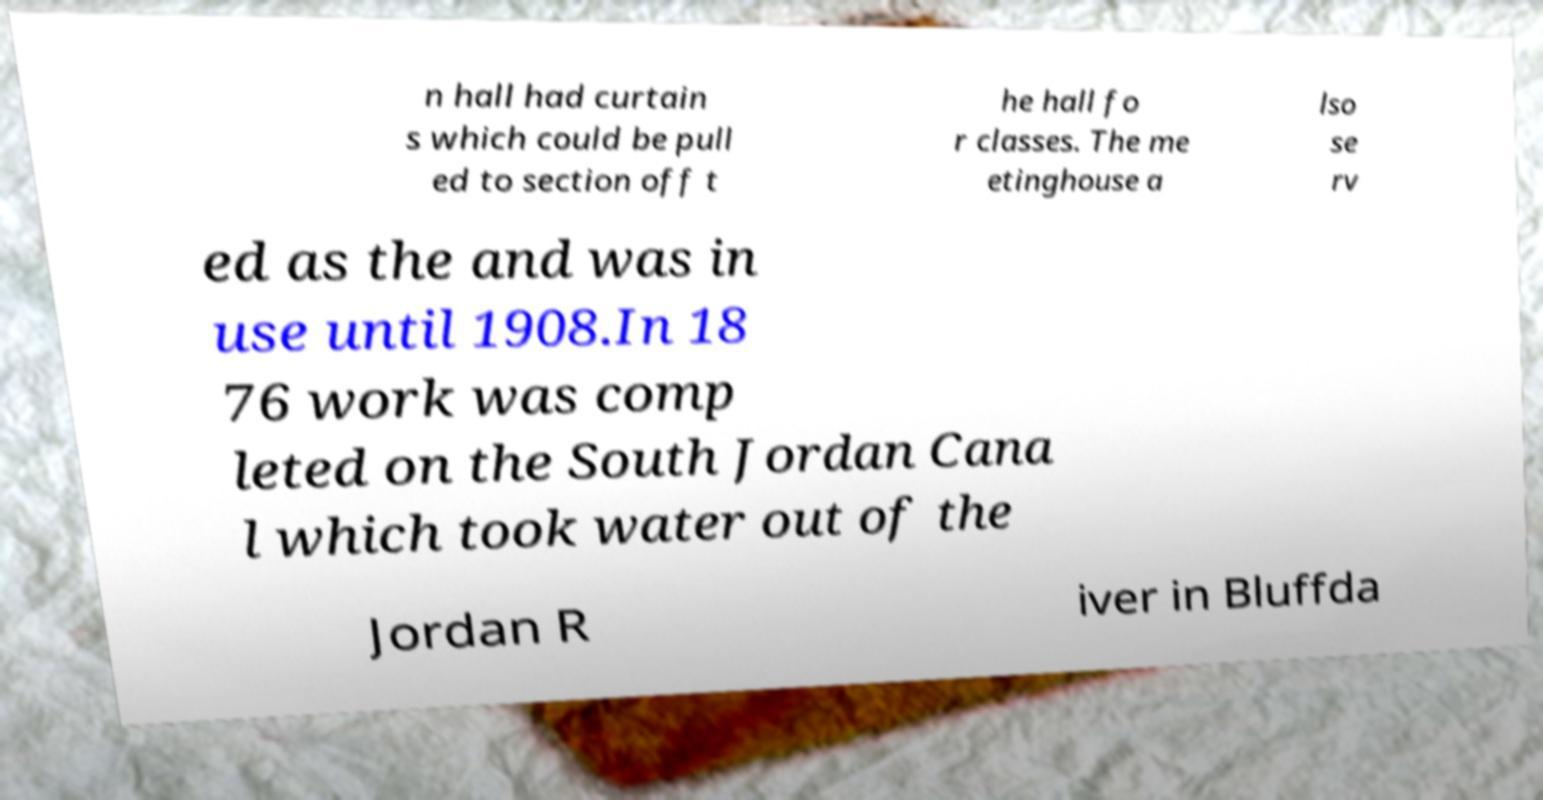There's text embedded in this image that I need extracted. Can you transcribe it verbatim? n hall had curtain s which could be pull ed to section off t he hall fo r classes. The me etinghouse a lso se rv ed as the and was in use until 1908.In 18 76 work was comp leted on the South Jordan Cana l which took water out of the Jordan R iver in Bluffda 